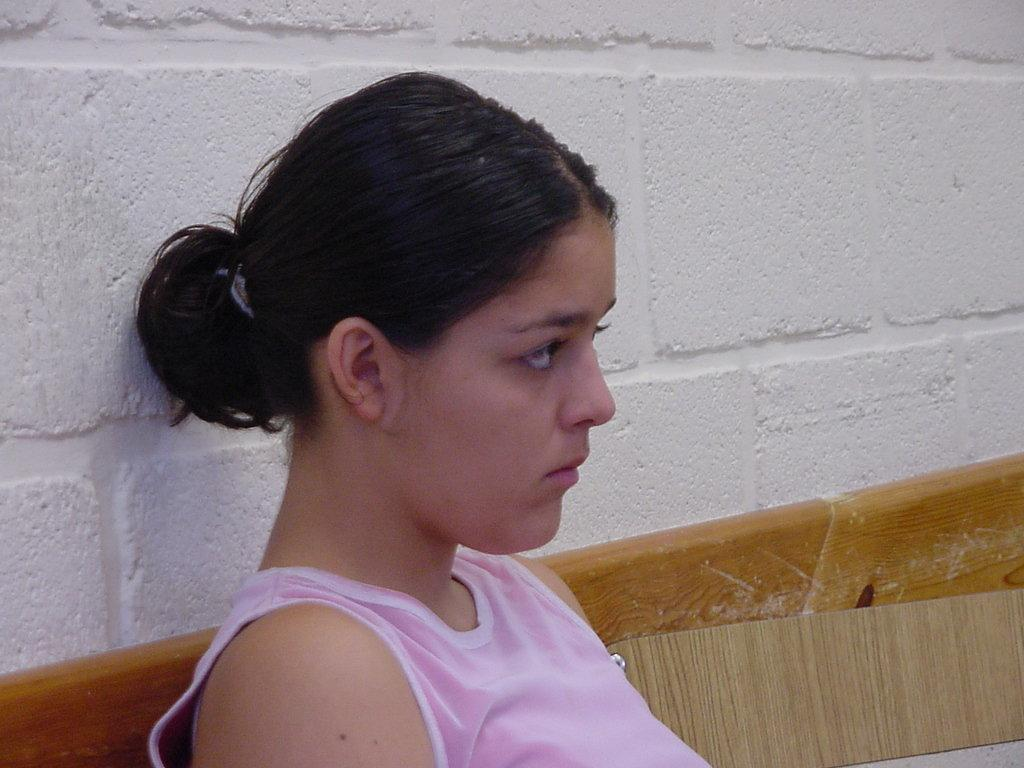What is the person in the image doing? The person is sitting on a bench in the image. What can be seen in the background of the image? There is a wall in the background of the image. Is the doctor treating the person sitting on the bench in the image? There is no doctor or any indication of medical treatment in the image; it only shows a person sitting on a bench with a wall in the background. 